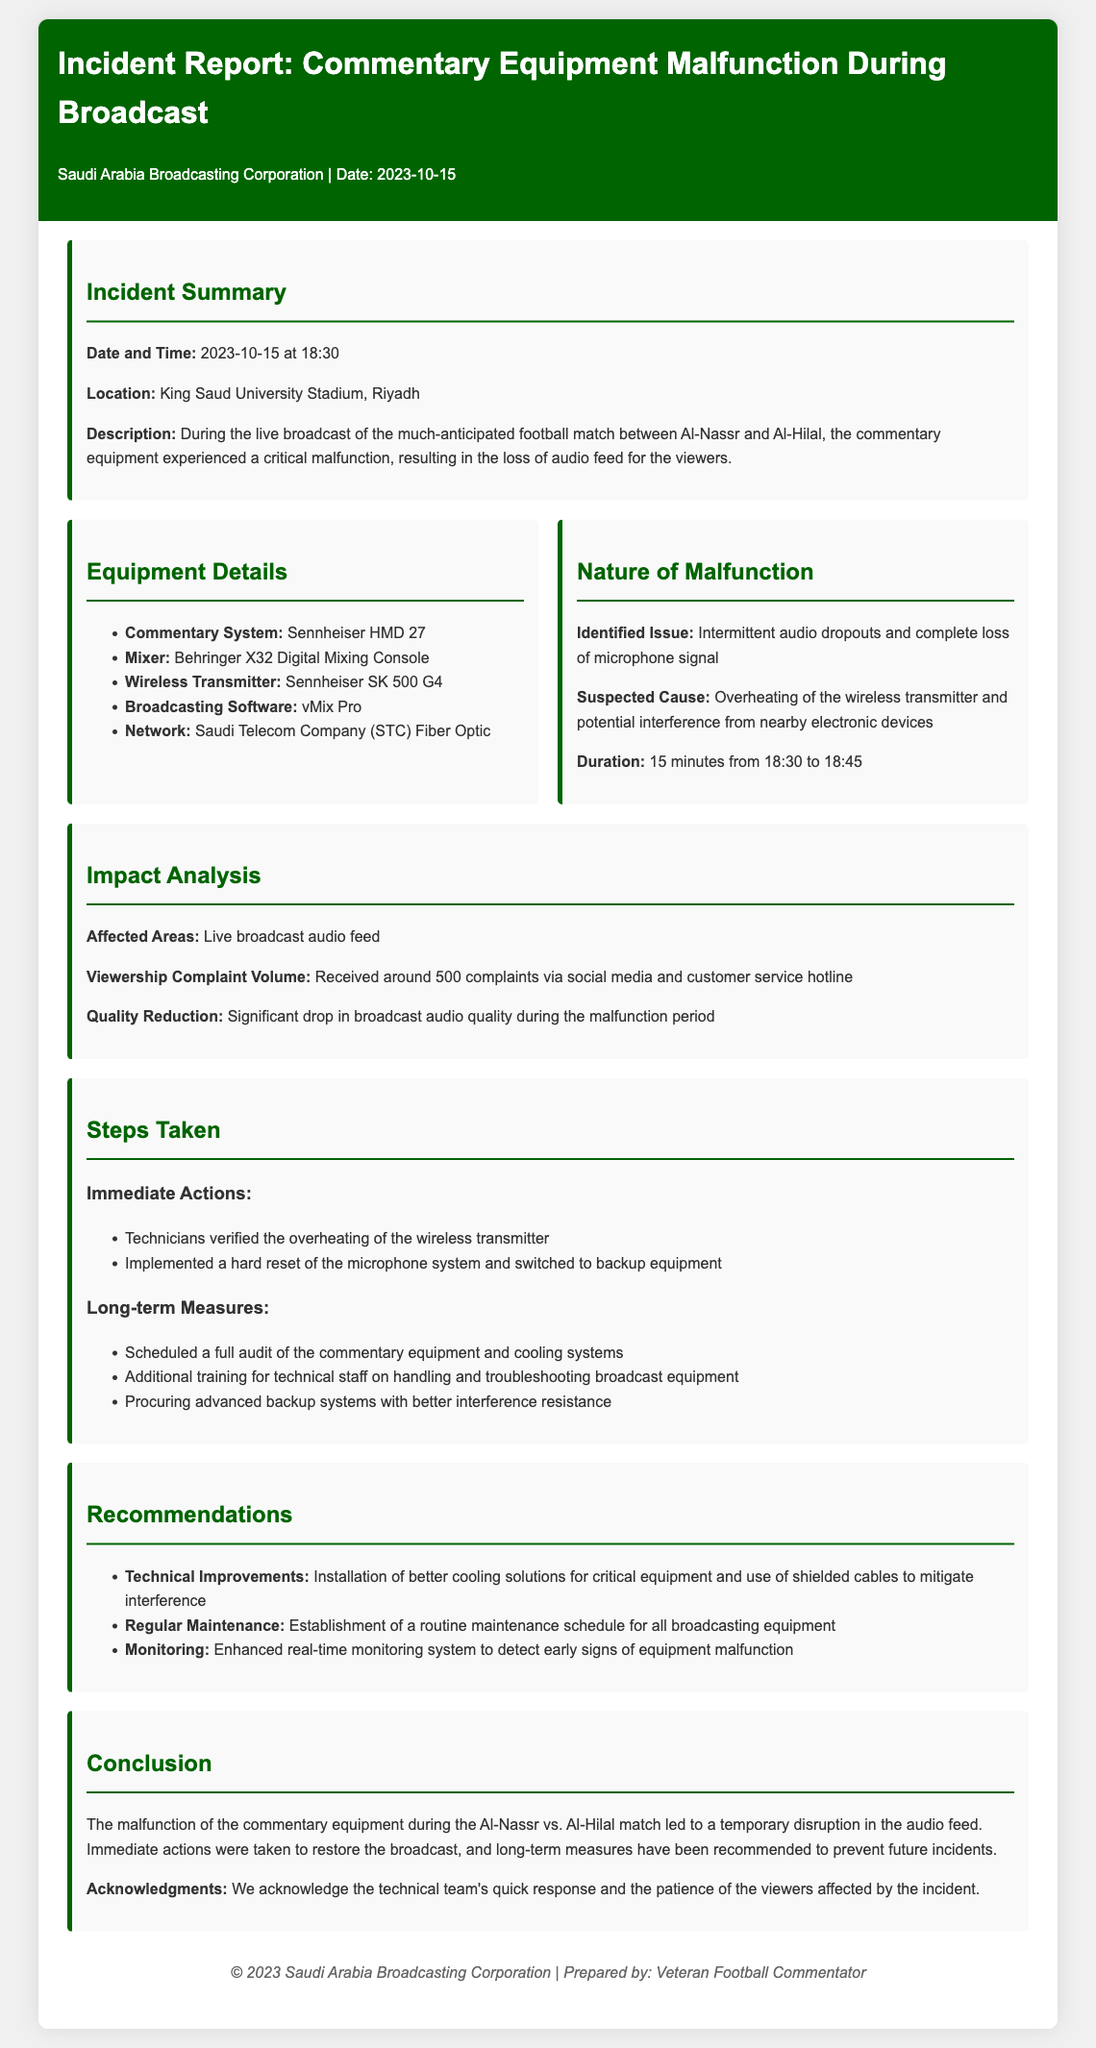What was the date of the incident? The incident occurred on 2023-10-15 as stated in the report.
Answer: 2023-10-15 What equipment was used for commentary? The report specifies that the commentary system used was Sennheiser HMD 27.
Answer: Sennheiser HMD 27 What was the suspected cause of the malfunction? The suspected cause mentioned was overheating of the wireless transmitter and potential interference.
Answer: Overheating of the wireless transmitter How long did the audio loss last? The loss of audio feed lasted for 15 minutes from 18:30 to 18:45.
Answer: 15 minutes How many complaints were received from viewers? The report states that approximately 500 complaints were received via social media and customer service hotline.
Answer: 500 complaints What immediate action was taken regarding the equipment? Technicians verified the overheating of the wireless transmitter as one of the immediate actions taken.
Answer: Verified the overheating of the wireless transmitter What long-term measure has been recommended for the equipment? One of the long-term measures recommended is to schedule a full audit of the commentary equipment and cooling systems.
Answer: Full audit of the commentary equipment and cooling systems What is one of the recommendations for technical improvements? The report recommends the installation of better cooling solutions for critical equipment.
Answer: Better cooling solutions for critical equipment 